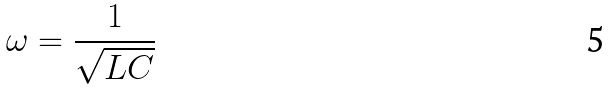Convert formula to latex. <formula><loc_0><loc_0><loc_500><loc_500>\omega = \frac { 1 } { \sqrt { L C } }</formula> 